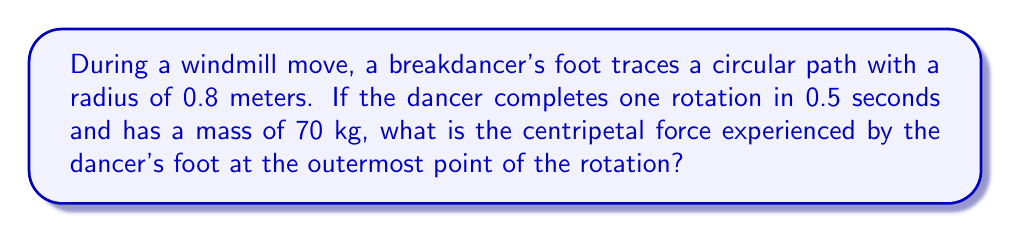Can you answer this question? To solve this problem, we need to follow these steps:

1. Calculate the angular velocity (ω):
   $$\omega = \frac{2\pi}{T}$$
   where T is the period of rotation.
   $$\omega = \frac{2\pi}{0.5} = 4\pi \text{ rad/s}$$

2. Calculate the linear velocity (v):
   $$v = r\omega$$
   where r is the radius of rotation.
   $$v = 0.8 \cdot 4\pi = 3.2\pi \text{ m/s}$$

3. Use the centripetal force formula:
   $$F_c = \frac{mv^2}{r}$$
   where m is the mass of the dancer.

4. Substitute the values:
   $$F_c = \frac{70 \cdot (3.2\pi)^2}{0.8}$$

5. Simplify:
   $$F_c = \frac{70 \cdot 10.24\pi^2}{0.8} = 2816\pi^2 \approx 27,771 \text{ N}$$

Therefore, the centripetal force experienced by the dancer's foot is approximately 27,771 N.
Answer: $2816\pi^2 \text{ N}$ (≈ 27,771 N) 